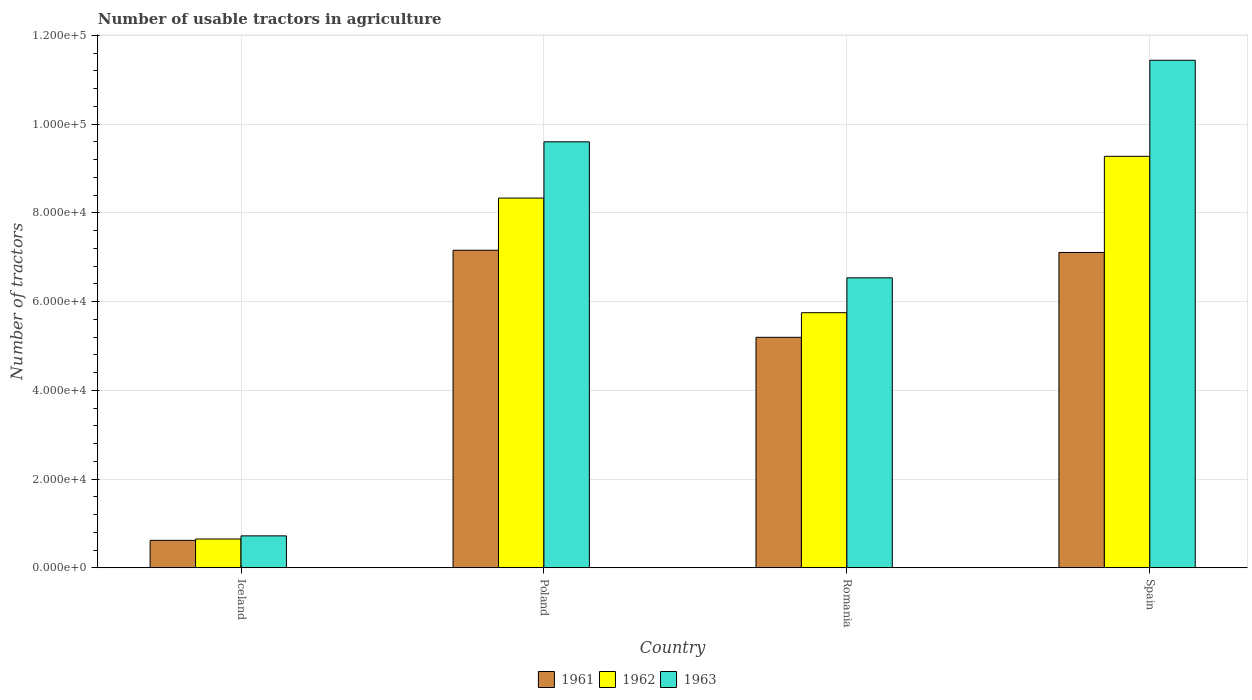How many bars are there on the 3rd tick from the left?
Keep it short and to the point. 3. In how many cases, is the number of bars for a given country not equal to the number of legend labels?
Offer a terse response. 0. What is the number of usable tractors in agriculture in 1961 in Iceland?
Your answer should be very brief. 6177. Across all countries, what is the maximum number of usable tractors in agriculture in 1962?
Your response must be concise. 9.28e+04. Across all countries, what is the minimum number of usable tractors in agriculture in 1963?
Provide a succinct answer. 7187. In which country was the number of usable tractors in agriculture in 1962 minimum?
Give a very brief answer. Iceland. What is the total number of usable tractors in agriculture in 1963 in the graph?
Your response must be concise. 2.83e+05. What is the difference between the number of usable tractors in agriculture in 1962 in Romania and that in Spain?
Ensure brevity in your answer.  -3.53e+04. What is the difference between the number of usable tractors in agriculture in 1961 in Spain and the number of usable tractors in agriculture in 1963 in Iceland?
Offer a terse response. 6.39e+04. What is the average number of usable tractors in agriculture in 1962 per country?
Your answer should be very brief. 6.00e+04. What is the difference between the number of usable tractors in agriculture of/in 1961 and number of usable tractors in agriculture of/in 1962 in Iceland?
Your answer should be compact. -302. In how many countries, is the number of usable tractors in agriculture in 1961 greater than 4000?
Keep it short and to the point. 4. What is the ratio of the number of usable tractors in agriculture in 1963 in Romania to that in Spain?
Offer a terse response. 0.57. What is the difference between the highest and the second highest number of usable tractors in agriculture in 1963?
Your response must be concise. 1.84e+04. What is the difference between the highest and the lowest number of usable tractors in agriculture in 1961?
Your answer should be very brief. 6.54e+04. In how many countries, is the number of usable tractors in agriculture in 1963 greater than the average number of usable tractors in agriculture in 1963 taken over all countries?
Your answer should be compact. 2. Is the sum of the number of usable tractors in agriculture in 1963 in Poland and Romania greater than the maximum number of usable tractors in agriculture in 1962 across all countries?
Offer a very short reply. Yes. What does the 3rd bar from the right in Iceland represents?
Your response must be concise. 1961. Are all the bars in the graph horizontal?
Offer a terse response. No. What is the difference between two consecutive major ticks on the Y-axis?
Your answer should be compact. 2.00e+04. Are the values on the major ticks of Y-axis written in scientific E-notation?
Ensure brevity in your answer.  Yes. Does the graph contain grids?
Your answer should be compact. Yes. Where does the legend appear in the graph?
Ensure brevity in your answer.  Bottom center. How many legend labels are there?
Provide a succinct answer. 3. What is the title of the graph?
Offer a very short reply. Number of usable tractors in agriculture. What is the label or title of the Y-axis?
Make the answer very short. Number of tractors. What is the Number of tractors in 1961 in Iceland?
Make the answer very short. 6177. What is the Number of tractors of 1962 in Iceland?
Give a very brief answer. 6479. What is the Number of tractors of 1963 in Iceland?
Ensure brevity in your answer.  7187. What is the Number of tractors of 1961 in Poland?
Make the answer very short. 7.16e+04. What is the Number of tractors in 1962 in Poland?
Ensure brevity in your answer.  8.33e+04. What is the Number of tractors in 1963 in Poland?
Offer a terse response. 9.60e+04. What is the Number of tractors of 1961 in Romania?
Your answer should be very brief. 5.20e+04. What is the Number of tractors of 1962 in Romania?
Your answer should be very brief. 5.75e+04. What is the Number of tractors in 1963 in Romania?
Ensure brevity in your answer.  6.54e+04. What is the Number of tractors of 1961 in Spain?
Make the answer very short. 7.11e+04. What is the Number of tractors of 1962 in Spain?
Your answer should be compact. 9.28e+04. What is the Number of tractors in 1963 in Spain?
Offer a terse response. 1.14e+05. Across all countries, what is the maximum Number of tractors of 1961?
Offer a very short reply. 7.16e+04. Across all countries, what is the maximum Number of tractors in 1962?
Keep it short and to the point. 9.28e+04. Across all countries, what is the maximum Number of tractors in 1963?
Your answer should be very brief. 1.14e+05. Across all countries, what is the minimum Number of tractors of 1961?
Keep it short and to the point. 6177. Across all countries, what is the minimum Number of tractors in 1962?
Offer a terse response. 6479. Across all countries, what is the minimum Number of tractors of 1963?
Your response must be concise. 7187. What is the total Number of tractors of 1961 in the graph?
Ensure brevity in your answer.  2.01e+05. What is the total Number of tractors in 1962 in the graph?
Offer a terse response. 2.40e+05. What is the total Number of tractors of 1963 in the graph?
Provide a succinct answer. 2.83e+05. What is the difference between the Number of tractors in 1961 in Iceland and that in Poland?
Offer a very short reply. -6.54e+04. What is the difference between the Number of tractors of 1962 in Iceland and that in Poland?
Your answer should be compact. -7.69e+04. What is the difference between the Number of tractors of 1963 in Iceland and that in Poland?
Ensure brevity in your answer.  -8.88e+04. What is the difference between the Number of tractors in 1961 in Iceland and that in Romania?
Provide a short and direct response. -4.58e+04. What is the difference between the Number of tractors of 1962 in Iceland and that in Romania?
Your answer should be compact. -5.10e+04. What is the difference between the Number of tractors of 1963 in Iceland and that in Romania?
Your response must be concise. -5.82e+04. What is the difference between the Number of tractors in 1961 in Iceland and that in Spain?
Make the answer very short. -6.49e+04. What is the difference between the Number of tractors in 1962 in Iceland and that in Spain?
Provide a succinct answer. -8.63e+04. What is the difference between the Number of tractors in 1963 in Iceland and that in Spain?
Offer a terse response. -1.07e+05. What is the difference between the Number of tractors of 1961 in Poland and that in Romania?
Your answer should be very brief. 1.96e+04. What is the difference between the Number of tractors of 1962 in Poland and that in Romania?
Your answer should be compact. 2.58e+04. What is the difference between the Number of tractors in 1963 in Poland and that in Romania?
Provide a succinct answer. 3.07e+04. What is the difference between the Number of tractors of 1962 in Poland and that in Spain?
Provide a succinct answer. -9414. What is the difference between the Number of tractors in 1963 in Poland and that in Spain?
Provide a short and direct response. -1.84e+04. What is the difference between the Number of tractors of 1961 in Romania and that in Spain?
Offer a very short reply. -1.91e+04. What is the difference between the Number of tractors of 1962 in Romania and that in Spain?
Give a very brief answer. -3.53e+04. What is the difference between the Number of tractors of 1963 in Romania and that in Spain?
Offer a very short reply. -4.91e+04. What is the difference between the Number of tractors in 1961 in Iceland and the Number of tractors in 1962 in Poland?
Provide a short and direct response. -7.72e+04. What is the difference between the Number of tractors of 1961 in Iceland and the Number of tractors of 1963 in Poland?
Ensure brevity in your answer.  -8.98e+04. What is the difference between the Number of tractors of 1962 in Iceland and the Number of tractors of 1963 in Poland?
Provide a succinct answer. -8.95e+04. What is the difference between the Number of tractors of 1961 in Iceland and the Number of tractors of 1962 in Romania?
Provide a short and direct response. -5.13e+04. What is the difference between the Number of tractors in 1961 in Iceland and the Number of tractors in 1963 in Romania?
Ensure brevity in your answer.  -5.92e+04. What is the difference between the Number of tractors in 1962 in Iceland and the Number of tractors in 1963 in Romania?
Provide a succinct answer. -5.89e+04. What is the difference between the Number of tractors in 1961 in Iceland and the Number of tractors in 1962 in Spain?
Give a very brief answer. -8.66e+04. What is the difference between the Number of tractors of 1961 in Iceland and the Number of tractors of 1963 in Spain?
Your answer should be very brief. -1.08e+05. What is the difference between the Number of tractors of 1962 in Iceland and the Number of tractors of 1963 in Spain?
Provide a succinct answer. -1.08e+05. What is the difference between the Number of tractors of 1961 in Poland and the Number of tractors of 1962 in Romania?
Offer a terse response. 1.41e+04. What is the difference between the Number of tractors in 1961 in Poland and the Number of tractors in 1963 in Romania?
Provide a succinct answer. 6226. What is the difference between the Number of tractors in 1962 in Poland and the Number of tractors in 1963 in Romania?
Ensure brevity in your answer.  1.80e+04. What is the difference between the Number of tractors of 1961 in Poland and the Number of tractors of 1962 in Spain?
Give a very brief answer. -2.12e+04. What is the difference between the Number of tractors of 1961 in Poland and the Number of tractors of 1963 in Spain?
Your answer should be compact. -4.28e+04. What is the difference between the Number of tractors of 1962 in Poland and the Number of tractors of 1963 in Spain?
Offer a very short reply. -3.11e+04. What is the difference between the Number of tractors of 1961 in Romania and the Number of tractors of 1962 in Spain?
Give a very brief answer. -4.08e+04. What is the difference between the Number of tractors in 1961 in Romania and the Number of tractors in 1963 in Spain?
Offer a very short reply. -6.25e+04. What is the difference between the Number of tractors of 1962 in Romania and the Number of tractors of 1963 in Spain?
Provide a short and direct response. -5.69e+04. What is the average Number of tractors of 1961 per country?
Offer a terse response. 5.02e+04. What is the average Number of tractors in 1962 per country?
Ensure brevity in your answer.  6.00e+04. What is the average Number of tractors of 1963 per country?
Offer a terse response. 7.07e+04. What is the difference between the Number of tractors in 1961 and Number of tractors in 1962 in Iceland?
Offer a terse response. -302. What is the difference between the Number of tractors in 1961 and Number of tractors in 1963 in Iceland?
Offer a very short reply. -1010. What is the difference between the Number of tractors in 1962 and Number of tractors in 1963 in Iceland?
Your answer should be very brief. -708. What is the difference between the Number of tractors of 1961 and Number of tractors of 1962 in Poland?
Provide a short and direct response. -1.18e+04. What is the difference between the Number of tractors in 1961 and Number of tractors in 1963 in Poland?
Provide a succinct answer. -2.44e+04. What is the difference between the Number of tractors of 1962 and Number of tractors of 1963 in Poland?
Provide a short and direct response. -1.27e+04. What is the difference between the Number of tractors in 1961 and Number of tractors in 1962 in Romania?
Provide a succinct answer. -5548. What is the difference between the Number of tractors of 1961 and Number of tractors of 1963 in Romania?
Offer a terse response. -1.34e+04. What is the difference between the Number of tractors of 1962 and Number of tractors of 1963 in Romania?
Provide a succinct answer. -7851. What is the difference between the Number of tractors in 1961 and Number of tractors in 1962 in Spain?
Offer a terse response. -2.17e+04. What is the difference between the Number of tractors in 1961 and Number of tractors in 1963 in Spain?
Offer a very short reply. -4.33e+04. What is the difference between the Number of tractors of 1962 and Number of tractors of 1963 in Spain?
Offer a terse response. -2.17e+04. What is the ratio of the Number of tractors of 1961 in Iceland to that in Poland?
Ensure brevity in your answer.  0.09. What is the ratio of the Number of tractors in 1962 in Iceland to that in Poland?
Offer a terse response. 0.08. What is the ratio of the Number of tractors of 1963 in Iceland to that in Poland?
Provide a succinct answer. 0.07. What is the ratio of the Number of tractors of 1961 in Iceland to that in Romania?
Give a very brief answer. 0.12. What is the ratio of the Number of tractors of 1962 in Iceland to that in Romania?
Your answer should be very brief. 0.11. What is the ratio of the Number of tractors in 1963 in Iceland to that in Romania?
Your answer should be very brief. 0.11. What is the ratio of the Number of tractors in 1961 in Iceland to that in Spain?
Offer a very short reply. 0.09. What is the ratio of the Number of tractors of 1962 in Iceland to that in Spain?
Make the answer very short. 0.07. What is the ratio of the Number of tractors of 1963 in Iceland to that in Spain?
Keep it short and to the point. 0.06. What is the ratio of the Number of tractors of 1961 in Poland to that in Romania?
Offer a terse response. 1.38. What is the ratio of the Number of tractors in 1962 in Poland to that in Romania?
Your answer should be compact. 1.45. What is the ratio of the Number of tractors of 1963 in Poland to that in Romania?
Provide a succinct answer. 1.47. What is the ratio of the Number of tractors of 1961 in Poland to that in Spain?
Provide a succinct answer. 1.01. What is the ratio of the Number of tractors of 1962 in Poland to that in Spain?
Provide a short and direct response. 0.9. What is the ratio of the Number of tractors in 1963 in Poland to that in Spain?
Your answer should be very brief. 0.84. What is the ratio of the Number of tractors in 1961 in Romania to that in Spain?
Your answer should be compact. 0.73. What is the ratio of the Number of tractors in 1962 in Romania to that in Spain?
Give a very brief answer. 0.62. What is the ratio of the Number of tractors of 1963 in Romania to that in Spain?
Give a very brief answer. 0.57. What is the difference between the highest and the second highest Number of tractors in 1962?
Make the answer very short. 9414. What is the difference between the highest and the second highest Number of tractors of 1963?
Give a very brief answer. 1.84e+04. What is the difference between the highest and the lowest Number of tractors of 1961?
Ensure brevity in your answer.  6.54e+04. What is the difference between the highest and the lowest Number of tractors of 1962?
Your answer should be compact. 8.63e+04. What is the difference between the highest and the lowest Number of tractors in 1963?
Your response must be concise. 1.07e+05. 